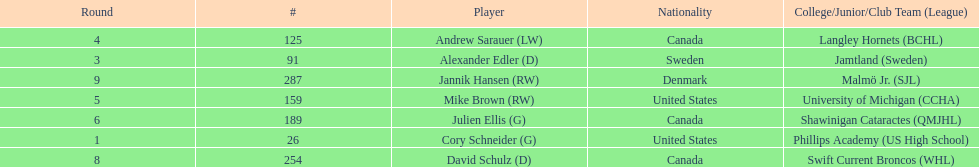List each player drafted from canada. Andrew Sarauer (LW), Julien Ellis (G), David Schulz (D). 